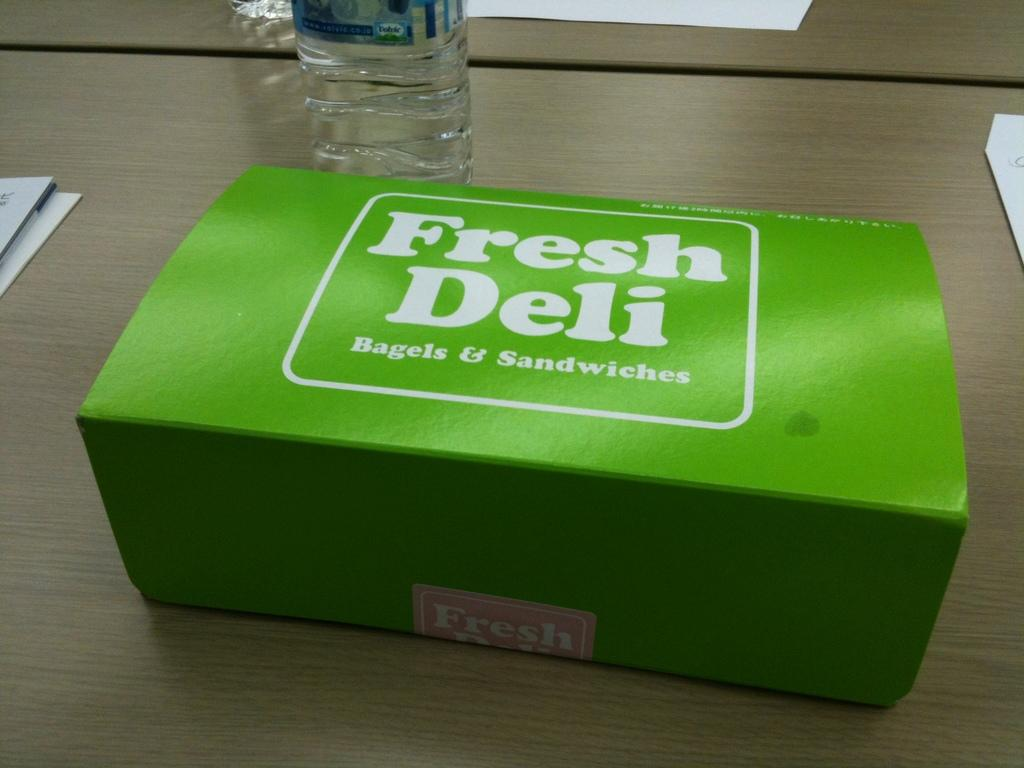<image>
Summarize the visual content of the image. A green Fresh Deli box sitting unopened on a table. 